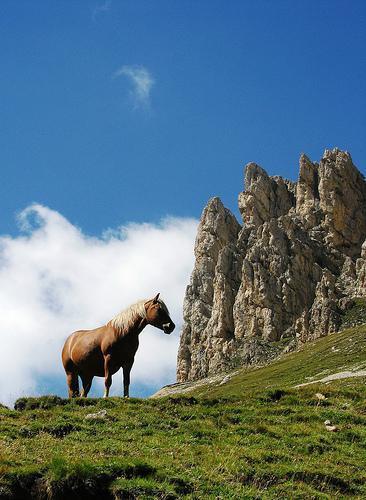How many horses are there?
Give a very brief answer. 1. 